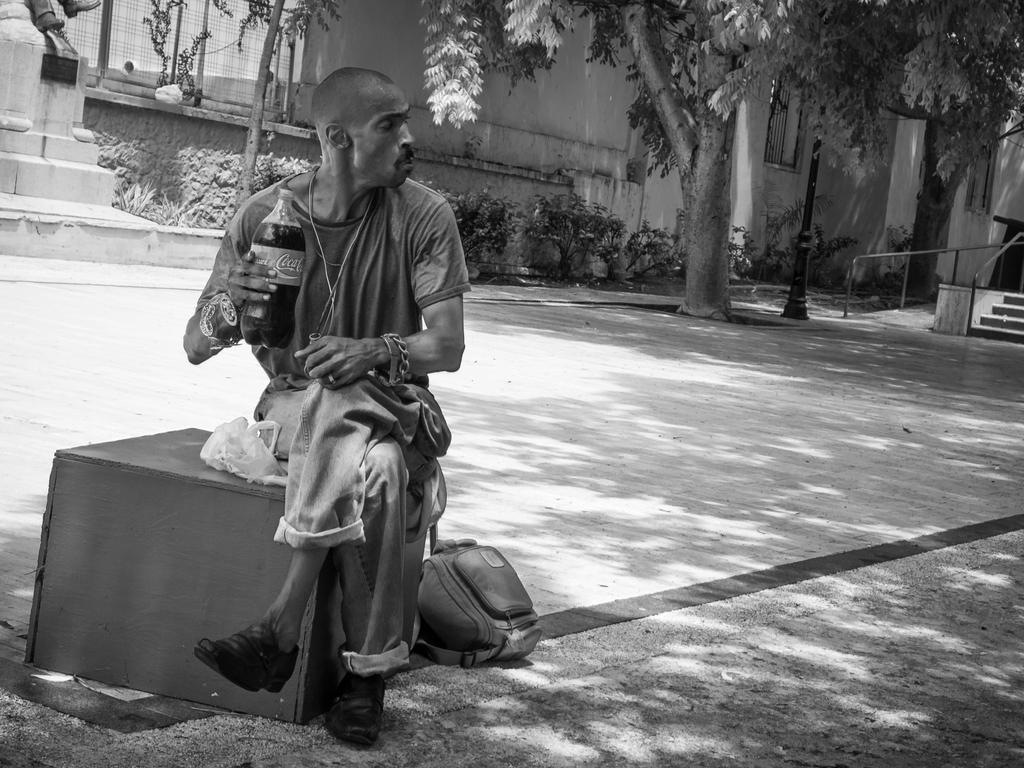How would you summarize this image in a sentence or two? It is a black and white image. In this picture, we can see a person is sitting on the box and holding a bottle. Here there is a bag on the walkway. Background we can see stairs, rods, pole, trees, plants, walls, mesh, grill. On the left side top corner, it seems like a statue. 